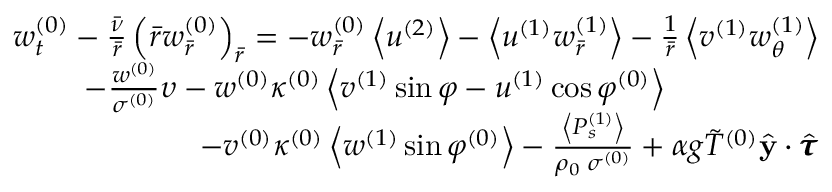Convert formula to latex. <formula><loc_0><loc_0><loc_500><loc_500>\begin{array} { r } { w _ { t } ^ { ( 0 ) } - \frac { \bar { \nu } } { \bar { r } } \left ( \bar { r } w _ { \bar { r } } ^ { ( 0 ) } \right ) _ { \bar { r } } = - w _ { \bar { r } } ^ { ( 0 ) } \left < u ^ { ( 2 ) } \right > - \left < u ^ { ( 1 ) } w _ { \bar { r } } ^ { ( 1 ) } \right > - \frac { 1 } { \bar { r } } \left < v ^ { ( 1 ) } w _ { \theta } ^ { ( 1 ) } \right > } \\ { - \frac { w ^ { ( 0 ) } } { \sigma ^ { ( 0 ) } } \upsilon - w ^ { ( 0 ) } \kappa ^ { ( 0 ) } \left < v ^ { ( 1 ) } \sin \varphi - u ^ { ( 1 ) } \cos \varphi ^ { ( 0 ) } \right > \quad } \\ { - v ^ { ( 0 ) } \kappa ^ { ( 0 ) } \left < w ^ { ( 1 ) } \sin \varphi ^ { ( 0 ) } \right > - \frac { \left < P _ { s } ^ { ( 1 ) } \right > } { \rho _ { 0 } \, \sigma ^ { ( 0 ) } } + \alpha g \tilde { T } ^ { ( 0 ) } \hat { y } \cdot \hat { \pm b { \tau } } } \end{array}</formula> 